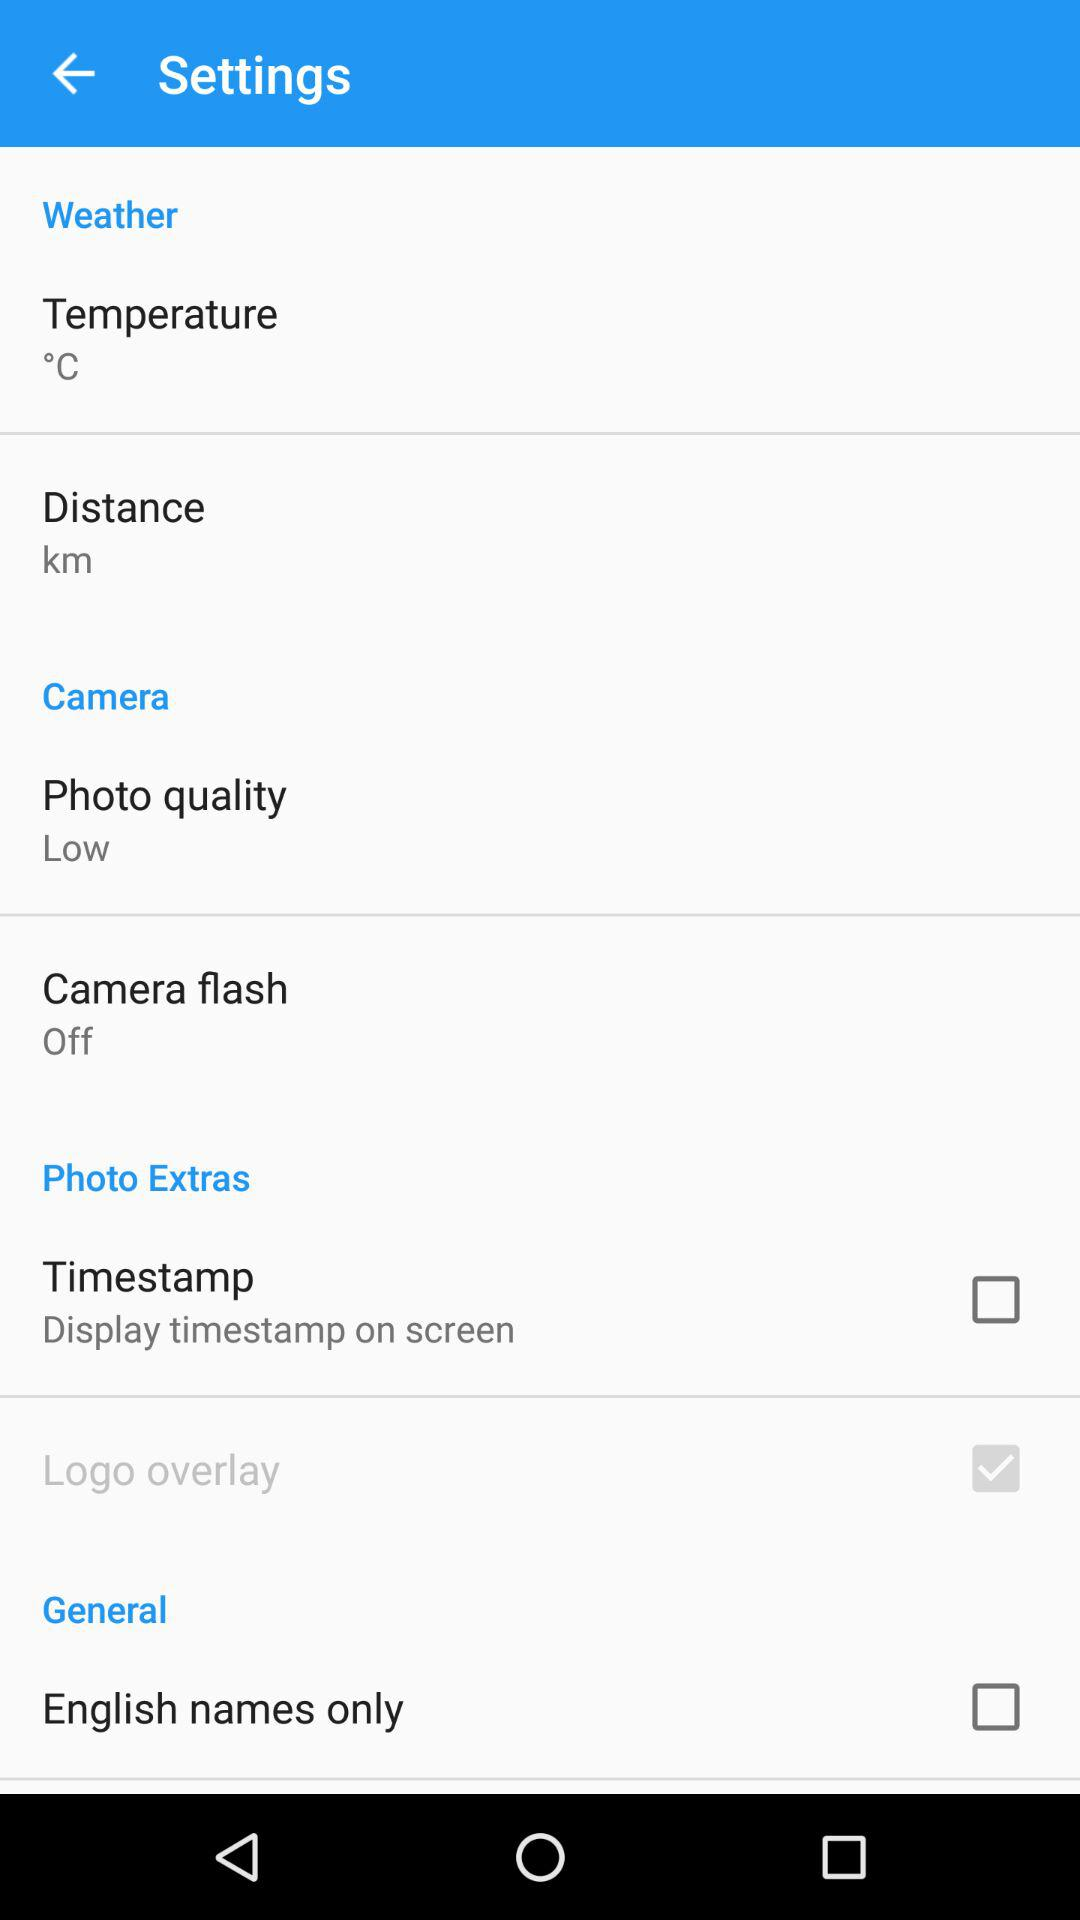What's the status of "English names only"? The status is "off". 